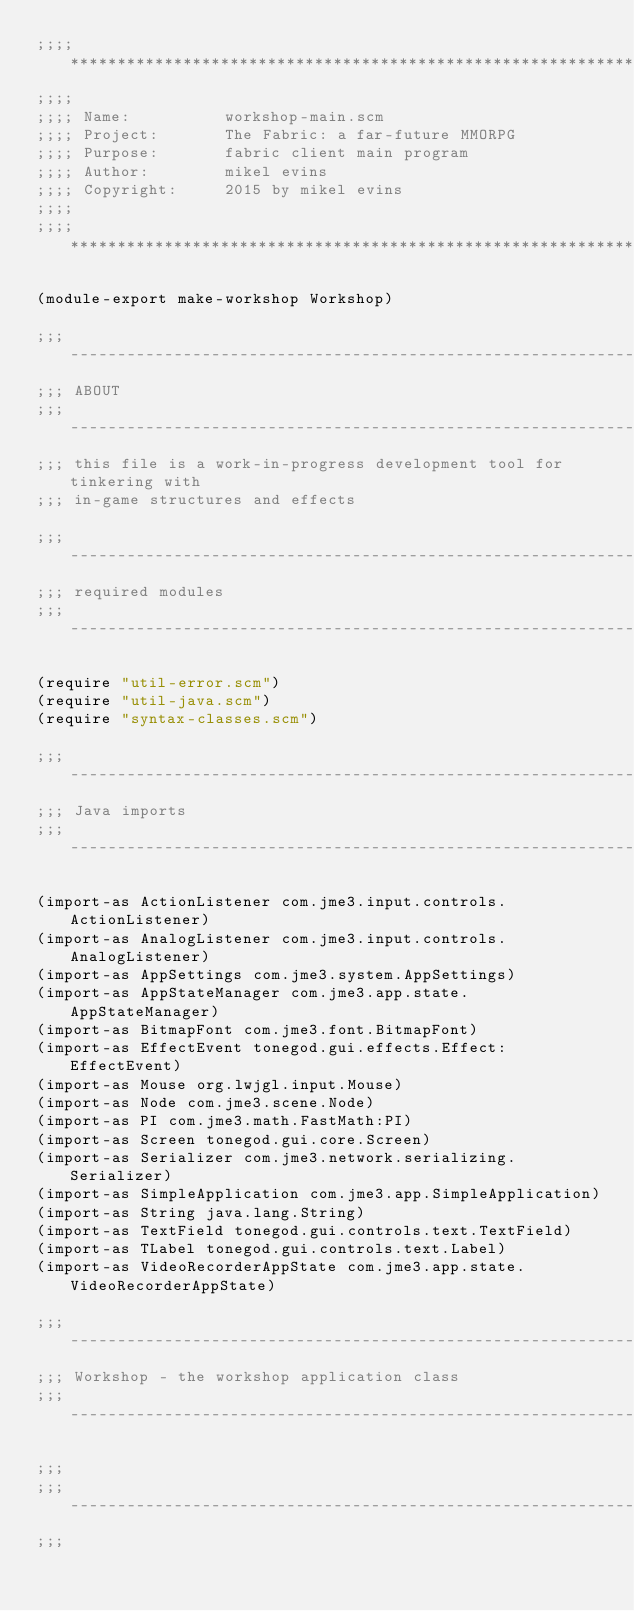Convert code to text. <code><loc_0><loc_0><loc_500><loc_500><_Scheme_>;;;; ***********************************************************************
;;;;
;;;; Name:          workshop-main.scm
;;;; Project:       The Fabric: a far-future MMORPG
;;;; Purpose:       fabric client main program
;;;; Author:        mikel evins
;;;; Copyright:     2015 by mikel evins
;;;;
;;;; ***********************************************************************

(module-export make-workshop Workshop)

;;; ---------------------------------------------------------------------
;;; ABOUT
;;; ---------------------------------------------------------------------
;;; this file is a work-in-progress development tool for tinkering with
;;; in-game structures and effects

;;; ---------------------------------------------------------------------
;;; required modules
;;; ---------------------------------------------------------------------

(require "util-error.scm")
(require "util-java.scm")
(require "syntax-classes.scm")

;;; ---------------------------------------------------------------------
;;; Java imports
;;; ---------------------------------------------------------------------

(import-as ActionListener com.jme3.input.controls.ActionListener)
(import-as AnalogListener com.jme3.input.controls.AnalogListener)
(import-as AppSettings com.jme3.system.AppSettings)
(import-as AppStateManager com.jme3.app.state.AppStateManager)
(import-as BitmapFont com.jme3.font.BitmapFont)
(import-as EffectEvent tonegod.gui.effects.Effect:EffectEvent)
(import-as Mouse org.lwjgl.input.Mouse)
(import-as Node com.jme3.scene.Node)
(import-as PI com.jme3.math.FastMath:PI)
(import-as Screen tonegod.gui.core.Screen)
(import-as Serializer com.jme3.network.serializing.Serializer)
(import-as SimpleApplication com.jme3.app.SimpleApplication)
(import-as String java.lang.String)
(import-as TextField tonegod.gui.controls.text.TextField)
(import-as TLabel tonegod.gui.controls.text.Label)
(import-as VideoRecorderAppState com.jme3.app.state.VideoRecorderAppState)

;;; ---------------------------------------------------------------------
;;; Workshop - the workshop application class
;;; ---------------------------------------------------------------------

;;; 
;;; ---------------------------------------------------------------------
;;; 
</code> 